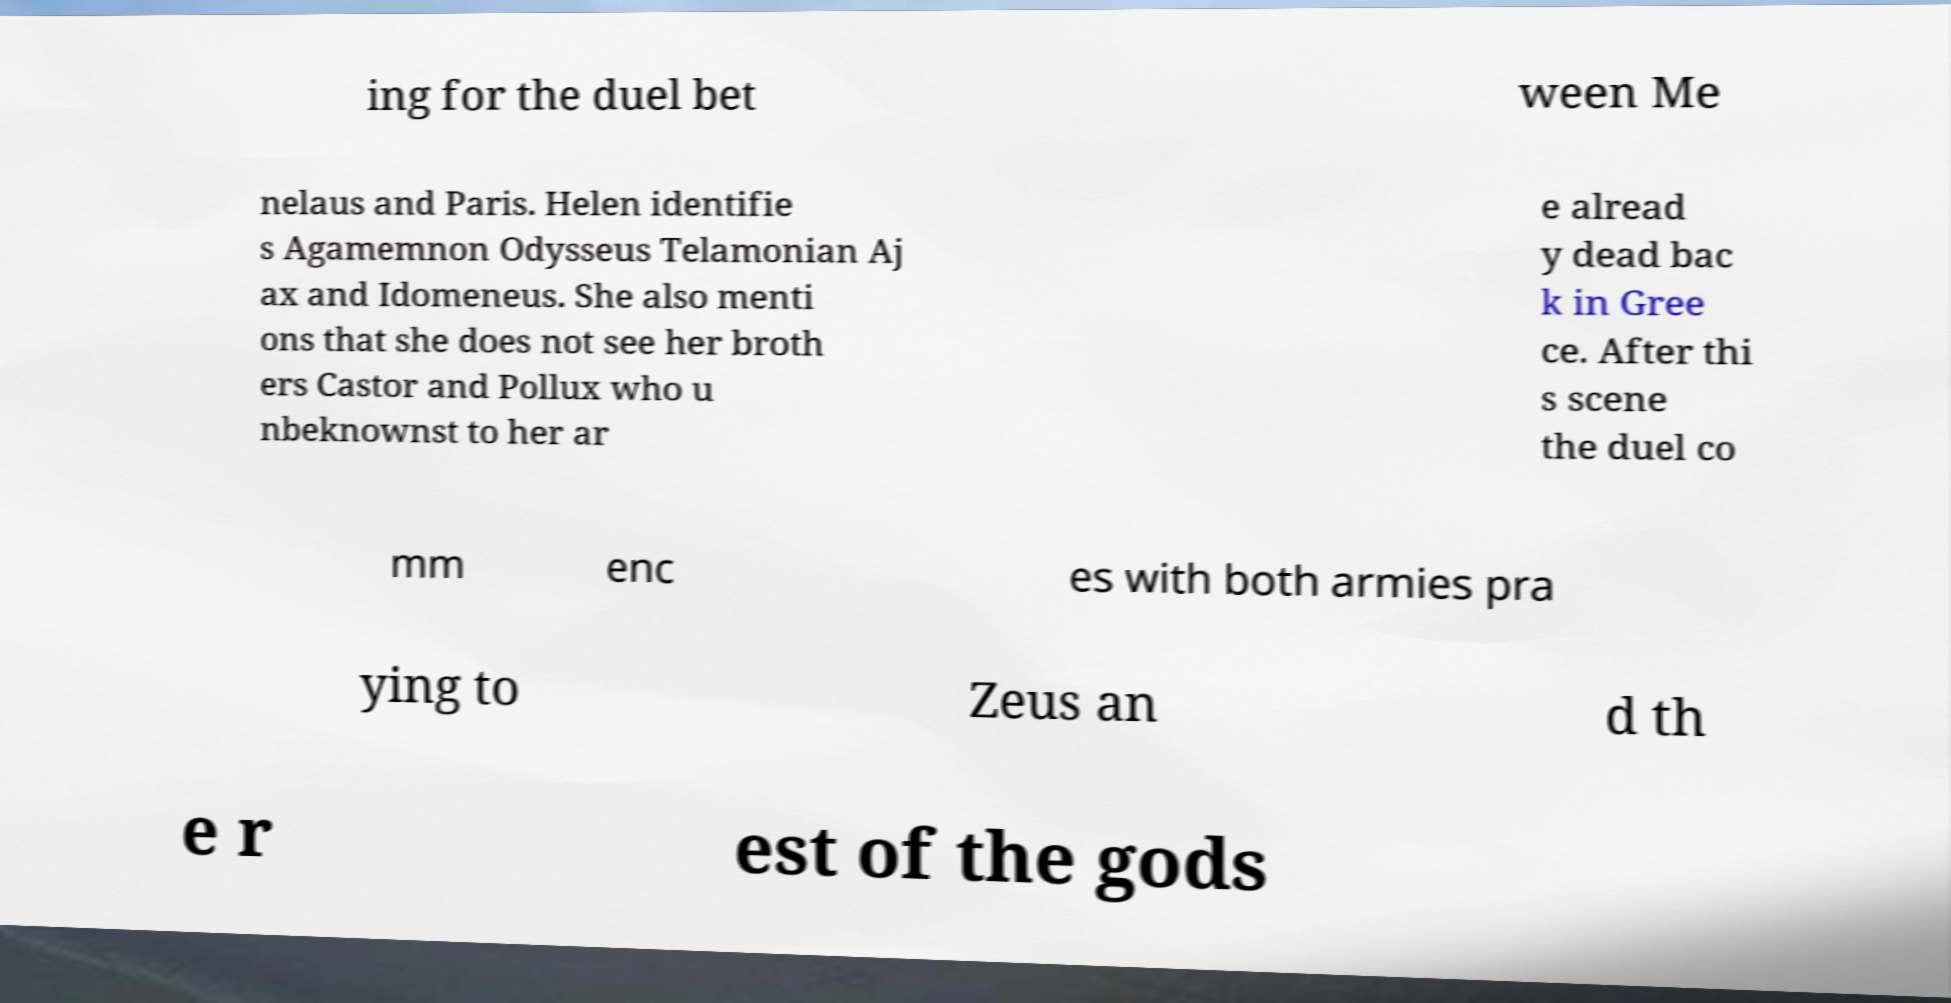Please identify and transcribe the text found in this image. ing for the duel bet ween Me nelaus and Paris. Helen identifie s Agamemnon Odysseus Telamonian Aj ax and Idomeneus. She also menti ons that she does not see her broth ers Castor and Pollux who u nbeknownst to her ar e alread y dead bac k in Gree ce. After thi s scene the duel co mm enc es with both armies pra ying to Zeus an d th e r est of the gods 